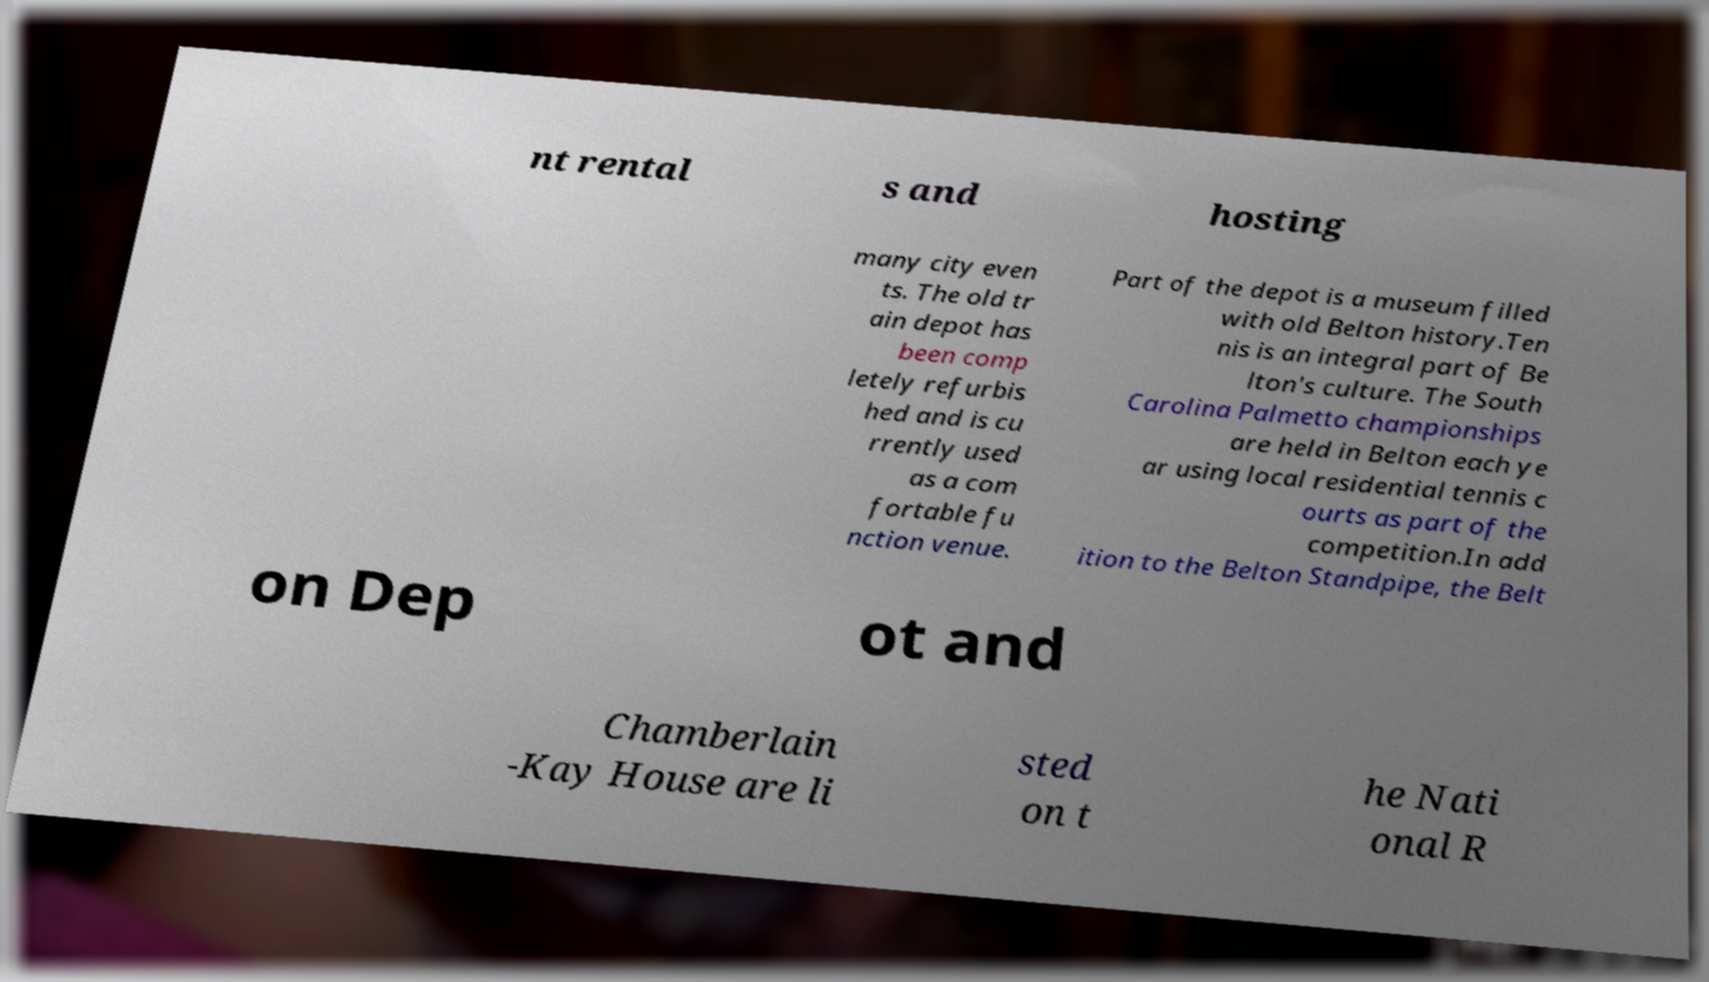Please read and relay the text visible in this image. What does it say? nt rental s and hosting many city even ts. The old tr ain depot has been comp letely refurbis hed and is cu rrently used as a com fortable fu nction venue. Part of the depot is a museum filled with old Belton history.Ten nis is an integral part of Be lton's culture. The South Carolina Palmetto championships are held in Belton each ye ar using local residential tennis c ourts as part of the competition.In add ition to the Belton Standpipe, the Belt on Dep ot and Chamberlain -Kay House are li sted on t he Nati onal R 